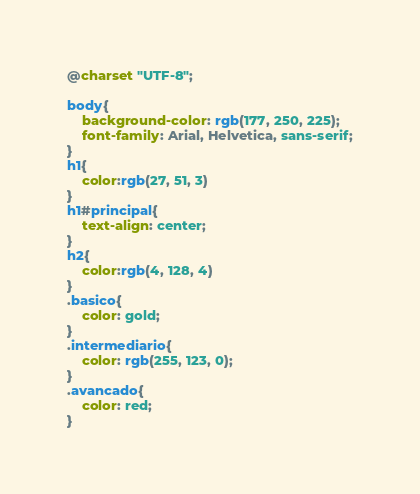Convert code to text. <code><loc_0><loc_0><loc_500><loc_500><_CSS_>@charset "UTF-8";

body{
    background-color: rgb(177, 250, 225);
    font-family: Arial, Helvetica, sans-serif;
}
h1{
    color:rgb(27, 51, 3)
}
h1#principal{
    text-align: center;
}
h2{
    color:rgb(4, 128, 4)
}
.basico{
    color: gold;
}
.intermediario{
    color: rgb(255, 123, 0);
}
.avancado{
    color: red;
}</code> 